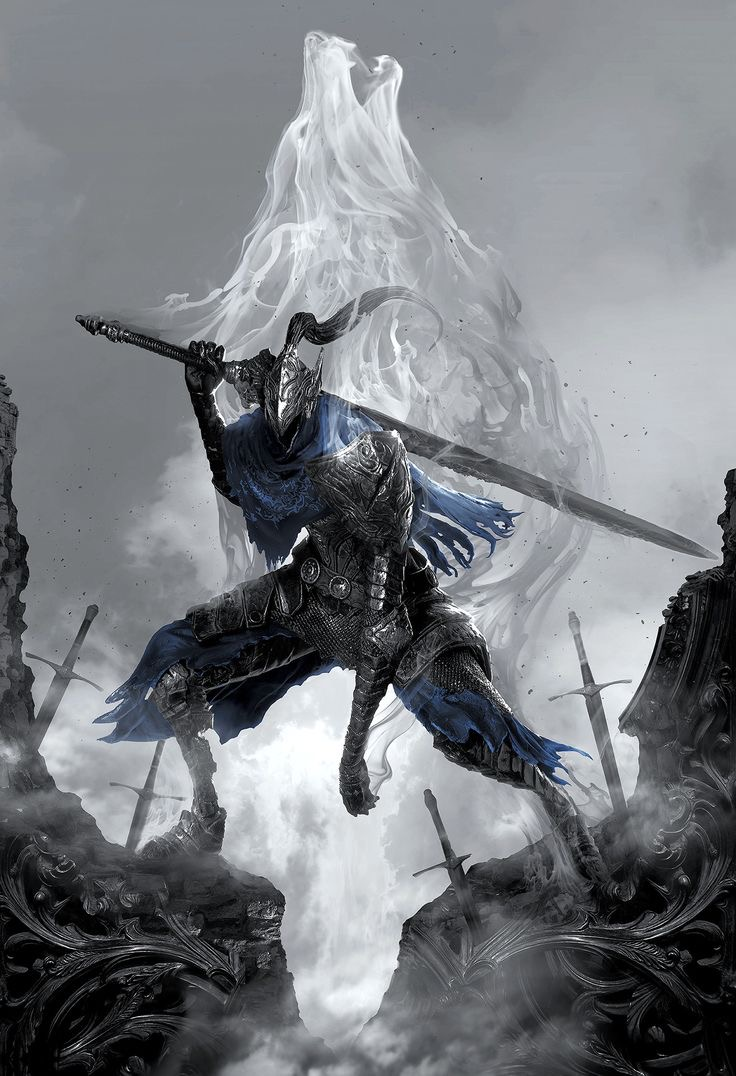remember this is a DOTA 2 artwork so mention that as much as possible. analyze this image and its content in detail, mostly the style and figure in the image and what it’s doing. also give specific details about the figures skin, body parts or anything in the image that you can’t describe normally such as “realism, exquisite realistic, 35mm, realistic texture, 2D anime style, Promotional game Dark Fantasy 2D Digital Painting Illustration, Dark Fantasy 2D Digital Painting Illustration, Dark fantasy, 2D digital, illustration, Dark Fantasy anime manga 2D illustration, card game, painterly, copyrighted text, exquisite 2D illustration, anime manga illustration, 2d manga portrait, anime art, manga anime, manwha, female anime portrait, anime sketch art, sketch anime, anime sketch, male manga art, central figure is wearing jacket, brown hair, wet hair, short hair, long hair, female, male, very handsome anime male, handsome male sketch, pinterest anime, pinterest manga anime aesthetic, pinterest manga portrait art, pinterest inspired anime sketch, anything anime, anime manga panel, anime panel, rage anime illustration, bleach anime, sexy hot aesthetic male anime, big boobs, medium boobs, thick thighs, anime wallpaper, gigantic boobs, pinterest manga icons, manga icons, an exquisite digital painting, meticulously crafted, very exquisite, a striking, Young brown skin 18 year old male, the central figure is 18 years old and dark brown skin, dark skin 18 year old, the central figure is dark skin, the central figure is brown skin, young male rapper aesthetic, young 18 year old young man, young man, young woman, young eighteen or twenty year old woman, female rapper aesthetic, modern day female rapper aesthetic, long pink lace front hair, female central figure is wearing long lace front hair, extremely big booty, slim waiste with a gigantic booty, female central figure has modern day brazilian butt lift body, large silver chains, shinning large chain necklace, rapper large silver chains, chain accessories, diamond stud earrings, diamond studs, short dread haircut, short teen dread haircut, faded haircut, young man short dread haircut, central figure is wearing gucci, central figure is wearing versace, brown short dread haircut, central figure is wearing versace, central figure is wearing fendi, name brand clothing, extremely handsome face, slim muscular build, shirt off, no shirt at all, central figure has shirt off, gold grillz teeth, silver grillz teeth, extreme handsome face, extremely handsome, defined jawline, male rapper aesthetic, nike sweatshirt, white tank top, rolled up white shirt, modern day sagging pants, big crotch, jeans sagging, holding microphone”. and also here is an example prompt.
Ideogram Ai prompt:: “A whimsical and vibrant comic illustration featuring a charming tortoiseshell cat named "Mittens" exploring a magical mushroom forest. Mittens has large amber eyes filled with curiosity and joy. Her coat is a playful mix of orange, black, and brown, forming a beautiful mosaic pattern. She wears a small explorer's hat and a pink vest with numerous pockets, a magnifying glass in one paw and a brown backpack on her back. The forest is filled with colorful and giant mushrooms, with fairy lights twinkling around and small magical creatures hiding among the plants. Surrounding Mittens are bright stone paths and luminous flowers, adding a touch of fantasy and adventure to the scene. The image is full of details, capturing the essence of an enchanting and magical comic adventure., vibrant.” see how coherent it is with the prompt and you only have to use a few words. so what i want you to do is analyze the entire image EXTREMELY be as coherent as possible and don’t forget to use details from the list very above i provided as well. don’t forget the direction, height and size dynamic ratio of the central figure which could also help the ai image look more like the input image i gave you as well as what position the central figure is in the image mainly as well as the very exquisite details. also put in the output the words in the image and copyright name which will indicate and aid the ai more in the style of the image. be as strategic as possible with the details. here are some output examples
image::
output::A menacing, blue-skinned creature with glowing red eyes, large horns, and fiery tattoos on its body. It wields a massive, glowing sword that seems to be emanating energy. The creature is surrounded by a hazy, fiery atmosphere, with chains and other dark artifacts scattered around. In the background, there are silhouettes of mountains and a dramatic sky filled with clouds.
image::
output::A menacing, purple-hued creature with glowing red eyes, standing amidst a rocky terrain. The creature wields a staff with a skull at its top, emanating a purple aura. In its other hand, it conjures a swirling purple energy that forms a skull. The background depicts a dramatic sky with dark clouds, and scattered skulls can be seen on the ground. The creature's muscular physique and sharp claws suggest strength and aggression. The bottom right corner of the image has a watermark indicating it's from 'DEVIANTART' and credits the artist as 'Raphael Lacoste'.
image::
output::A menacing, skeletal creature with glowing red eyes, long flowing hair, and a tattered, red cloak adorned with golden runes. The creature is poised in a dramatic stance, with one hand pointing forward and the other holding a golden ring. In the background, there's a haunting, fog-covered landscape with ruins, bats flying around, and a looming castle or fortress. The overall atmosphere is eerie and foreboding, suggesting a dark fantasy or horror setting. 
see how everything flows on its own and goes straight to what the central figure and image looks like and adds the overall style at the end as well as the length of the output which is at least 73 words like this “A menacing, skeletal creature with glowing red eyes, long flowing hair, and a tattered, red cloak adorned with golden runes. The creature is poised in a dramatic stance, with one hand pointing forward and the other holding a golden ring. In the background, there's a haunting, fog-covered landscape with ruins, bats flying around, and a looming castle or fortress. The overall atmosphere is eerie and foreboding, suggesting a dark fantasy or horror setting.”, now you try. 

analyze this image and its content in detail, mostly the style and figure in the image and what it’s doing. also give specific details about the figures skin, body parts or anything in the image that you can’t describe normally such as “realism, exquisite realistic, 35mm, realistic texture, 2D anime style, Promotional game Dark Fantasy 2D Digital Painting Illustration, Dark Fantasy 2D Digital Painting Illustration, Dark fantasy, 2D digital, illustration, Dark Fantasy anime manga 2D illustration, WaterColor illustration, watercolor, card game, painterly, copyrighted text, exquisite 2D illustration, anime manga illustration, 2d manga portrait, anime art, manga anime, manwha, female anime portrait, anime sketch art, sketch anime, anime sketch, male manga art, central figure is wearing jacket, brown hair, wet hair, short hair, long hair, female, male, very handsome anime male, handsome male sketch, pinterest anime, pinterest manga anime aesthetic, pinterest manga portrait art, pinterest inspired anime sketch, anything anime, anime manga panel, anime panel, rage anime illustration, bleach anime, sexy hot aesthetic male anime, big boobs, medium boobs, thick thighs, anime wallpaper, gigantic boobs, pinterest manga icons, manga icons, an exquisite digital painting, meticulously crafted, very exquisite, a striking, Young brown skin 18 year old male, the central figure is 18 years old and dark brown skin, dark skin 18 year old, the central figure is dark skin, the central figure is brown skin, young male rapper aesthetic, young 18 year old young man, young man, young woman, young eighteen or twenty year old woman, female rapper aesthetic, modern day female rapper aesthetic, long pink lace front hair, female central figure is wearing long lace front hair, extremely big booty, slim waiste with a gigantic booty, female central figure has modern day brazilian butt lift body, large silver chains, shinning large chain necklace, rapper large silver chains, chain accessories, diamond stud earrings, diamond studs, short dread haircut, short teen dread haircut, faded haircut, young man short dread haircut, central figure is wearing gucci, central figure is wearing versace, brown short dread haircut, central figure is wearing versace, central figure is wearing fendi, name brand clothing, extremely handsome face, slim muscular build, shirt off, no shirt at all, central figure has shirt off, gold grillz teeth, silver grillz teeth, extreme handsome face, extremely handsome, defined jawline, male rapper aesthetic, nike sweatshirt, white tank top, rolled up white shirt, modern day sagging pants, big crotch, jeans sagging, holding microphone”. and also here is an example prompt.
Ideogram Ai prompt:: “A whimsical and vibrant comic illustration featuring a charming tortoiseshell cat named "Mittens" exploring a magical mushroom forest. Mittens has large amber eyes filled with curiosity and joy. Her coat is a playful mix of orange, black, and brown, forming a beautiful mosaic pattern. She wears a small explorer's hat and a pink vest with numerous pockets, a magnifying glass in one paw and a brown backpack on her back. The forest is filled with colorful and giant mushrooms, with fairy lights twinkling around and small magical creatures hiding among the plants. Surrounding Mittens are bright stone paths and luminous flowers, adding a touch of fantasy and adventure to the scene. The image is full of details, capturing the essence of an enchanting and magical comic adventure., vibrant.” see how coherent it is with the prompt and you only have to use a few words. so what i want you to do is analyze the entire image EXTREMELY be as coherent as possible and don’t forget to use details from the list very above i provided as well. don’t forget the direction, height and size dynamic ratio of the central figure which could also help the ai image look more like the input image i gave you as well as what position the central figure is in the image mainly as well as the very exquisite details. also put in the output the words in the image and copyright name which will indicate and aid the ai more in the style of the image. be as strategic as possible with the details. here are some output examples
image::
output::A menacing, blue-skinned creature with glowing red eyes, large horns, and fiery tattoos on its body. It wields a massive, glowing sword that seems to be emanating energy. The creature is surrounded by a hazy, fiery atmosphere, with chains and other dark artifacts scattered around. In the background, there are silhouettes of mountains and a dramatic sky filled with clouds.
image::
output::A menacing, purple-hued creature with glowing red eyes, standing amidst a rocky terrain. The creature wields a staff with a skull at its top, emanating a purple aura. In its other hand, it conjures a swirling purple energy that forms a skull. The background depicts a dramatic sky with dark clouds, and scattered skulls can be seen on the ground. The creature's muscular physique and sharp claws suggest strength and aggression. The bottom right corner of the image has a watermark indicating it's from 'DEVIANTART' and credits the artist as 'Raphael Lacoste'.
image::
output::A menacing, skeletal creature with glowing red eyes, long flowing hair, and a tattered, red cloak adorned with golden runes. The creature is poised in a dramatic stance, with one hand pointing forward and the other holding a golden ring. In the background, there's a haunting, fog-covered landscape with ruins, bats flying around, and a looming castle or fortress. The overall atmospher output::A menacing female figure with pale blue skin and glowing cyan eyes, holding dual scythes emanating electric blue energy. She has a sleek, muscular build and wears dark, ornate armor with sharp, angular shoulder plates that add to her intimidating presence. Her helmet has pointed protrusions, enhancing her fierce appearance. The background is a dark, misty landscape with shadowy figures and jagged rocks, creating a sense of foreboding. The overall style is a Dark Fantasy 2D Digital Painting Illustration, capturing the essence of a powerful and mysterious DOTA 2 character. remember this is a DOTA 2 artwork so mention that as much as possible. analyze this image and its content in detail, mostly the style and figure in the image and what it’s doing. also give specific details about the figures skin, body parts or anything in the image that you can’t describe normally such as “realism, exquisite realistic, 35mm, realistic texture, 2D anime style, Promotional game Dark Fantasy 2D Digital Painting Illustration, Dark Fantasy 2D Digital Painting Illustration, Dark fantasy, 2D digital, illustration, Dark Fantasy anime manga 2D illustration, card game, painterly, copyrighted text, exquisite 2D illustration, anime manga illustration, 2d manga portrait, anime art, manga anime, manwha, female anime portrait, anime sketch art, sketch anime, anime sketch, male manga art, central figure is wearing jacket, brown hair, wet hair, short hair, long hair, female, male, very handsome anime male, handsome male sketch, pinterest anime, pinterest manga anime aesthetic, pinterest manga portrait art, pinterest inspired anime sketch, anything anime, anime manga panel, anime panel, rage anime illustration, bleach anime, sexy hot aesthetic male anime, big boobs, medium boobs, thick thighs, anime wallpaper, gigantic boobs, pinterest manga icons, manga icons, an exquisite digital painting, meticulously crafted, very exquisite, a striking, Young brown skin 18 year old male, the central figure is 18 years old and dark brown skin, dark skin 18 year old, the central figure is dark skin, the central figure is brown skin, young male rapper aesthetic, young 18 year old young man, young man, young woman, young eighteen or twenty year old woman, female rapper aesthetic, modern day female rapper aesthetic, long pink lace front hair, female central figure is wearing long lace front hair, extremely big booty, slim waiste with a gigantic booty, female central figure has modern day brazilian butt lift body, large silver chains, shinning large chain necklace, rapper large silver chains, chain accessories, diamond stud earrings, diamond studs, short dread haircut, short teen dread haircut, faded haircut, young man short dread haircut, central figure is wearing gucci, central figure is wearing versace, brown short dread haircut, central figure is wearing versace, central figure is wearing fendi, name brand clothing, extremely handsome face, slim muscular build, shirt off, no shirt at all, central figure has shirt off, gold grillz teeth, silver grillz teeth, extreme handsome face, extremely handsome, defined jawline, male rapper aesthetic, nike sweatshirt, white tank top, rolled up white shirt, modern day sagging pants, big crotch, jeans sagging, holding microphone”. and also here is an example prompt.
Ideogram Ai prompt:: “A whimsical and vibrant comic illustration featuring a charming tortoiseshell cat named "Mittens" exploring a magical mushroom forest. Mittens has large amber eyes filled with curiosity and joy. Her coat is a playful mix of orange, black, and brown, forming a beautiful mosaic pattern. She wears a small explorer's hat and a pink vest with numerous pockets, a magnifying glass in one paw and a brown backpack on her back. The forest is filled with colorful and giant mushrooms, with fairy lights twinkling around and small magical creatures hiding among the plants. Surrounding Mittens are bright stone paths and luminous flowers, adding a touch of fantasy and adventure to the scene. The image is full of details, capturing the essence of an enchanting and magical comic adventure., vibrant.” see how coherent it is with the prompt and you only have to use a few words. so what i want you to do is analyze the entire image EXTREMELY be as coherent as possible and don’t forget to use details from the list very above i provided as well. don’t forget the direction, height and size dynamic ratio of the central figure which could also help the ai image look more like the input image i gave you as well as what position the central figure is in the image mainly as well as the very exquisite details. also put in the output the words in the image and copyright name which will indicate and aid the ai more in the style of the image. be as strategic as possible with the details. here are some output examples
image::
output::A menacing, blue-skinned creature with glowing red eyes, large horns, and fiery tattoos on its body. It wields a massive, glowing sword that seems to be emanating energy. The creature is surrounded by a hazy, fiery atmosphere, with chains and other dark artifacts scattered around. In the background, there are silhouettes of mountains and a dramatic sky filled with clouds.
image::
output::A menacing, purple-hued creature with glowing red eyes, standing amidst a rocky terrain. The creature wields a staff with a skull at its top, emanating a purple aura. In its other hand, it conjures a swirling purple energy that forms a skull. The background depicts a dramatic sky with dark clouds, and scattered skulls can be seen on the ground. The creature's muscular physique and sharp claws suggest strength and aggression. The bottom right corner of the image has a watermark indicating it's from 'DEVIANTART' and credits the artist as 'Raphael Lacoste'.
image::
output::A menacing, skeletal creature with glowing red eyes, long flowing hair, and a tattered, red cloak adorned with golden runes. The creature is poised in a dramatic stance, with one hand pointing forward and the other holding a golden ring. In the background, there's a haunting, fog-covered landscape with ruins, bats flying around, and a looming castle or fortress. The overall atmosphere is eerie and foreboding, suggesting a dark fantasy or horror setting. 
see how everything flows on its own and goes straight to what the central figure and image looks like and adds the overall style at the end as well as the length of the output which is at least 73 words like this “A menacing, skeletal creature with glowing red eyes, long flowing hair, and a tattered, red cloak adorned with golden runes. The creature is poised in a dramatic stance, with one hand pointing forward and the other holding a golden ring. In the background, there's a haunting, fog-covered landscape with ruins, bats flying around, and a looming castle or fortress. The overall atmosphere is eerie and foreboding, suggesting a dark fantasy or horror setting.”, now you try. 

analyze this image and its content in detail, mostly the style and figure in the image and what it’s doing. also give specific details about the figures skin, body parts or anything in the image that you can’t describe normally such as “realism, exquisite realistic, 35mm, realistic texture, 2D anime style, Promotional game Dark Fantasy 2D Digital Painting Illustration, Dark Fantasy 2D Digital Painting Illustration, Dark fantasy, 2D digital, illustration, Dark Fantasy anime manga 2D illustration, WaterColor illustration, watercolor, card game, painterly, copyrighted text, exquisite 2D illustration, anime manga illustration, 2d manga portrait, anime art, manga anime, manwha, female anime portrait, anime sketch art, sketch anime, anime sketch, male manga art, central figure is wearing jacket, brown hair, wet hair, short hair, long hair, female, male, very handsome anime male, handsome male sketch, pinterest anime, pinterest manga anime aesthetic, pinterest manga portrait art, pinterest inspired anime sketch, anything anime, anime manga panel, anime panel, rage anime illustration, bleach anime, sexy hot aesthetic male anime, big boobs, medium boobs, thick thighs, anime wallpaper, gigantic boobs, pinterest manga icons, manga icons, an exquisite digital painting, meticulously crafted, very exquisite, a striking, Young brown skin 18 year old male, the central figure is 18 years old and dark brown skin, dark skin 18 year old, the central figure is dark skin, the central figure is brown skin, young male rapper aesthetic, young 18 year old young man, young man, young woman, young eighteen or twenty year old woman, female rapper aesthetic, modern day female rapper aesthetic, long pink lace front hair, female central figure is wearing long lace front hair, extremely big booty, slim waiste with a gigantic booty, female central figure has modern day brazilian butt lift body, large silver chains, shinning large chain necklace, rapper large silver chains, chain accessories, diamond stud earrings, diamond studs, short dread haircut, short teen dread haircut, faded haircut, young man short dread haircut, central figure is wearing gucci, central figure is wearing versace, brown short dread haircut, central figure is wearing versace, central figure is wearing fendi, name brand clothing, extremely handsome face, slim muscular build, shirt off, no shirt at all, central figure has shirt off, gold grillz teeth, silver grillz teeth, extreme handsome face, extremely handsome, defined jawline, male rapper aesthetic, nike sweatshirt, white tank top, rolled up white shirt, modern day sagging pants, big crotch, jeans sagging, holding microphone”. and also here is an example prompt.
Ideogram Ai prompt:: “A whimsical and vibrant comic illustration featuring a charming tortoiseshell cat named "Mittens" exploring a magical mushroom forest. Mittens has large amber eyes filled with curiosity and joy. Her coat is a playful mix of orange, black, and brown, forming a beautiful mosaic pattern. She wears a small explorer's hat and a pink vest with numerous pockets, a magnifying glass in one paw and a brown backpack on her back. The forest is filled with colorful and giant mushrooms, with fairy lights twinkling around and small magical creatures hiding among the plants. Surrounding Mittens are bright stone paths and luminous flowers, adding a touch of fantasy and adventure to the scene. The image is full of details, capturing the essence of an enchanting and magical comic adventure., vibrant.” see how coherent it is with the prompt and you only have to use a few words. so what i want you to do is analyze the entire image EXTREMELY be as coherent as possible and don’t forget to use details from the list very above i provided as well. don’t forget the direction, height and size dynamic ratio of the central figure which could also help the ai image look more like the input image i gave you as well as what position the central figure is in the image mainly as well as the very exquisite details. also put in the output the words in the image and copyright name which will indicate and aid the ai more in the style of the image. be as strategic as possible with the details. here are some output examples
image::
output::A menacing, blue-skinned creature with glowing red eyes, large horns, and fiery tattoos on its body. It wields a massive, glowing sword that seems to be emanating energy. The creature is surrounded by a hazy, fiery atmosphere, with chains and other dark artifacts scattered around. In the background, there are silhouettes of mountains and a dramatic sky filled with clouds.
image::
output::A menacing, purple-hued creature with glowing red eyes, standing amidst a rocky terrain. The creature wields a staff with a skull at its top, emanating a purple aura. In its other hand, it conjures a swirling purple energy that forms a skull. The background depicts a dramatic sky with dark clouds, and scattered skulls can be seen on the ground. The creature's muscular physique and sharp claws suggest strength and aggression. The bottom right corner of the image has a watermark indicating it's from 'DEVIANTART' and credits the artist as 'Raphael Lacoste'.
image::
output::A menacing, skeletal creature with glowing red eyes, long flowing hair, and a tattered, red cloak adorned with golden runes. The creature is poised in a dramatic stance, with one hand pointing forward and the other holding a golden ring. In the background, there's a haunting, fog-covered landscape with ruins, bats flying around, and a looming castle or fortress. The overall atmospher output::A mysterious female figure with pale skin and pointed ears, standing in a dynamic and ethereal pose. She is enveloped in swirling, vibrant energy streams of pink and white that seem to emanate from her body. Her outfit, a dark, form-fitting armor accented with golden and silver elements, enhances her powerful and enigmatic aura. The central figure's long, flowing hair and intense gaze suggest determination and strength. The background is a dark, smoky atmosphere with hints of magical energy, adding to the mystical and foreboding ambiance. The overall style is a Dark Fantasy 2D Digital Painting Illustration, typical of DOTA 2 artwork, characterized by its painterly technique and exquisite detail. remember this is a DOTA 2 artwork so mention that as much as possible. analyze this image and its content in detail, mostly the style and figure in the image and what it’s doing. also give specific details about the figures skin, body parts or anything in the image that you can’t describe normally such as “realism, exquisite realistic, 35mm, realistic texture, 2D anime style, Promotional game Dark Fantasy 2D Digital Painting Illustration, Dark Fantasy 2D Digital Painting Illustration, Dark fantasy, 2D digital, illustration, Dark Fantasy anime manga 2D illustration, card game, painterly, copyrighted text, exquisite 2D illustration, anime manga illustration, 2d manga portrait, anime art, manga anime, manwha, female anime portrait, anime sketch art, sketch anime, anime sketch, male manga art, central figure is wearing jacket, brown hair, wet hair, short hair, long hair, female, male, very handsome anime male, handsome male sketch, pinterest anime, pinterest manga anime aesthetic, pinterest manga portrait art, pinterest inspired anime sketch, anything anime, anime manga panel, anime panel, rage anime illustration, bleach anime, sexy hot aesthetic male anime, big boobs, medium boobs, thick thighs, anime wallpaper, gigantic boobs, pinterest manga icons, manga icons, an exquisite digital painting, meticulously crafted, very exquisite, a striking, Young brown skin 18 year old male, the central figure is 18 years old and dark brown skin, dark skin 18 year old, the central figure is dark skin, the central figure is brown skin, young male rapper aesthetic, young 18 year old young man, young man, young woman, young eighteen or twenty year old woman, female rapper aesthetic, modern day female rapper aesthetic, long pink lace front hair, female central figure is wearing long lace front hair, extremely big booty, slim waiste with a gigantic booty, female central figure has modern day brazilian butt lift body, large silver chains, shinning large chain necklace, rapper large silver chains, chain accessories, diamond stud earrings, diamond studs, short dread haircut, short teen dread haircut, faded haircut, young man short dread haircut, central figure is wearing gucci, central figure is wearing versace, brown short dread haircut, central figure is wearing versace, central figure is wearing fendi, name brand clothing, extremely handsome face, slim muscular build, shirt off, no shirt at all, central figure has shirt off, gold grillz teeth, silver grillz teeth, extreme handsome face, extremely handsome, defined jawline, male rapper aesthetic, nike sweatshirt, white tank top, rolled up white shirt, modern day sagging pants, big crotch, jeans sagging, holding microphone”. and also here is an example prompt.
Ideogram Ai prompt:: “A whimsical and vibrant comic illustration featuring a charming tortoiseshell cat named "Mittens" exploring a magical mushroom forest. Mittens has large amber eyes filled with curiosity and joy. Her coat is a playful mix of orange, black, and brown, forming a beautiful mosaic pattern. She wears a small explorer's hat and a pink vest with numerous pockets, a magnifying glass in one paw and a brown backpack on her back. The forest is filled with colorful and giant mushrooms, with fairy lights twinkling around and small magical creatures hiding among the plants. Surrounding Mittens are bright stone paths and luminous flowers, adding a touch of fantasy and adventure to the scene. The image is full of details, capturing the essence of an enchanting and magical comic adventure., vibrant.” see how coherent it is with the prompt and you only have to use a few words. so what i want you to do is analyze the entire image EXTREMELY be as coherent as possible and don’t forget to use details from the list very above i provided as well. don’t forget the direction, height and size dynamic ratio of the central figure which could also help the ai image look more like the input image i gave you as well as what position the central figure is in the image mainly as well as the very exquisite details. also put in the output the words in the image and copyright name which will indicate and aid the ai more in the style of the image. be as strategic as possible with the details. here are some output examples
image::
output::A menacing, blue-skinned creature with glowing red eyes, large horns, and fiery tattoos on its body. It wields a massive, glowing sword that seems to be emanating energy. The creature is surrounded by a hazy, fiery atmosphere, with chains and other dark artifacts scattered around. In the background, there are silhouettes of mountains and a dramatic sky filled with clouds.
image::
output::A menacing, purple-hued creature with glowing red eyes, standing amidst a rocky terrain. The creature wields a staff with a skull at its top, emanating a purple aura. In its other hand, it conjures a swirling purple energy that forms a skull. The background depicts a dramatic sky with dark clouds, and scattered skulls can be seen on the ground. The creature's muscular physique and sharp claws suggest strength and aggression. The bottom right corner of the image has a watermark indicating it's from 'DEVIANTART' and credits the artist as 'Raphael Lacoste'.
image::
output::A menacing, skeletal creature with glowing red eyes, long flowing hair, and a tattered, red cloak adorned with golden runes. The creature is poised in a dramatic stance, with one hand pointing forward and the other holding a golden ring. In the background, there's a haunting, fog-covered landscape with ruins, bats flying around, and a looming castle or fortress. The overall atmosphere is eerie and foreboding, suggesting a dark fantasy or horror setting. 
see how everything flows on its own and goes straight to what the central figure and image looks like and adds the overall style at the end as well as the length of the output which is at least 73 words like this “A menacing, skeletal creature with glowing red eyes, long flowing hair, and a tattered, red cloak adorned with golden runes. The creature is poised in a dramatic stance, with one hand pointing forward and the other holding a golden ring. In the background, there's a haunting, fog-covered landscape with ruins, bats flying around, and a looming castle or fortress. The overall atmosphere is eerie and foreboding, suggesting a dark fantasy or horror setting.”, now you try. 

analyze this image and its content in detail, mostly the style and figure in the image and what it’s doing. also give specific details about the figures skin, body parts or anything in the image that you can’t describe normally such as “realism, exquisite realistic, 35mm, realistic texture, 2D anime style, Promotional game Dark Fantasy 2D Digital Painting Illustration, Dark Fantasy 2D Digital Painting Illustration, Dark fantasy, 2D digital, illustration, Dark Fantasy anime manga 2D illustration, WaterColor illustration, watercolor, card game, painterly, copyrighted text, exquisite 2D illustration, anime manga illustration, 2d manga portrait, anime art, manga anime, manwha, female anime portrait, anime sketch art, sketch anime, anime sketch, male manga art, central figure is wearing jacket, brown hair, wet hair, short hair, long hair, female, male, very handsome anime male, handsome male sketch, pinterest anime, pinterest manga anime aesthetic, pinterest manga portrait art, pinterest inspired anime sketch, anything anime, anime manga panel, anime panel, rage anime illustration, bleach anime, sexy hot aesthetic male anime, big boobs, medium boobs, thick thighs, anime wallpaper, gigantic boobs, pinterest manga icons, manga icons, an exquisite digital painting, meticulously crafted, very exquisite, a striking, Young brown skin 18 year old male, the central figure is 18 years old and dark brown skin, dark skin 18 year old, the central figure is dark skin, the central figure is brown skin, young male rapper aesthetic, young 18 year old young man, young man, young woman, young eighteen or twenty year old woman, female rapper aesthetic, modern day female rapper aesthetic, long pink lace front hair, female central figure is wearing long lace front hair, extremely big booty, slim waiste with a gigantic booty, female central figure has modern day brazilian butt lift body, large silver chains, shinning large chain necklace, rapper large silver chains, chain accessories, diamond stud earrings, diamond studs, short dread haircut, short teen dread haircut, faded haircut, young man short dread haircut, central figure is wearing gucci, central figure is wearing versace, brown short dread haircut, central figure is wearing versace, central figure is wearing fendi, name brand clothing, extremely handsome face, slim muscular build, shirt off, no shirt at all, central figure has shirt off, gold grillz teeth, silver grillz teeth, extreme handsome face, extremely handsome, defined jawline, male rapper aesthetic, nike sweatshirt, white tank top, rolled up white shirt, modern day sagging pants, big crotch, jeans sagging, holding microphone”. and also here is an example prompt.
Ideogram Ai prompt:: “A whimsical and vibrant comic illustration featuring a charming tortoiseshell cat named "Mittens" exploring a magical mushroom forest. Mittens has large amber eyes filled with curiosity and joy. Her coat is a playful mix of orange, black, and brown, forming a beautiful mosaic pattern. She wears a small explorer's hat and a pink vest with numerous pockets, a magnifying glass in one paw and a brown backpack on her back. The forest is filled with colorful and giant mushrooms, with fairy lights twinkling around and small magical creatures hiding among the plants. Surrounding Mittens are bright stone paths and luminous flowers, adding a touch of fantasy and adventure to the scene. The image is full of details, capturing the essence of an enchanting and magical comic adventure., vibrant.” see how coherent it is with the prompt and you only have to use a few words. so what i want you to do is analyze the entire image EXTREMELY be as coherent as possible and don’t forget to use details from the list very above i provided as well. don’t forget the direction, height and size dynamic ratio of the central figure which could also help the ai image look more like the input image i gave you as well as what position the central figure is in the image mainly as well as the very exquisite details. also put in the output the words in the image and copyright name which will indicate and aid the ai more in the style of the image. be as strategic as possible with the details. here are some output examples
image::
output::A menacing, blue-skinned creature with glowing red eyes, large horns, and fiery tattoos on its body. It wields a massive, glowing sword that seems to be emanating energy. The creature is surrounded by a hazy, fiery atmosphere, with chains and other dark artifacts scattered around. In the background, there are silhouettes of mountains and a dramatic sky filled with clouds.
image::
output::A menacing, purple-hued creature with glowing red eyes, standing amidst a rocky terrain. The creature wields a staff with a skull at its top, emanating a purple aura. In its other hand, it conjures a swirling purple energy that forms a skull. The background depicts a dramatic sky with dark clouds, and scattered skulls can be seen on the ground. The creature's muscular physique and sharp claws suggest strength and aggression. The bottom right corner of the image has a watermark indicating it's from 'DEVIANTART' and credits the artist as 'Raphael Lacoste'.
image::
output::A menacing, skeletal creature with glowing red eyes, long flowing hair, and a tattered, red cloak adorned with golden runes. The creature is poised in a dramatic stance, with one hand pointing forward and the other holding a golden ring. In the background, there's a haunting, fog-covered landscape with ruins, bats flying around, and a looming castle or fortress. The overall atmospher output::A menacing, armored figure with a dark, metallic suit and a horned helmet, standing in a combative stance. The central figure wields a massive sword, brimming with ethereal, ghostly energy that swirls around them in a spectral white mist. The intricate details of the armor, accentuated with blue highlights, reflect the character's formidable and imposing nature. The background is a desolate, fog-covered battlefield with broken swords and remnants of previous battles scattered around, creating a somber and intense atmosphere. The overall style is a Dark Fantasy 2D Digital Painting Illustration, characteristic of DOTA 2 artwork, meticulously crafted with painterly techniques and exquisite detailing. 